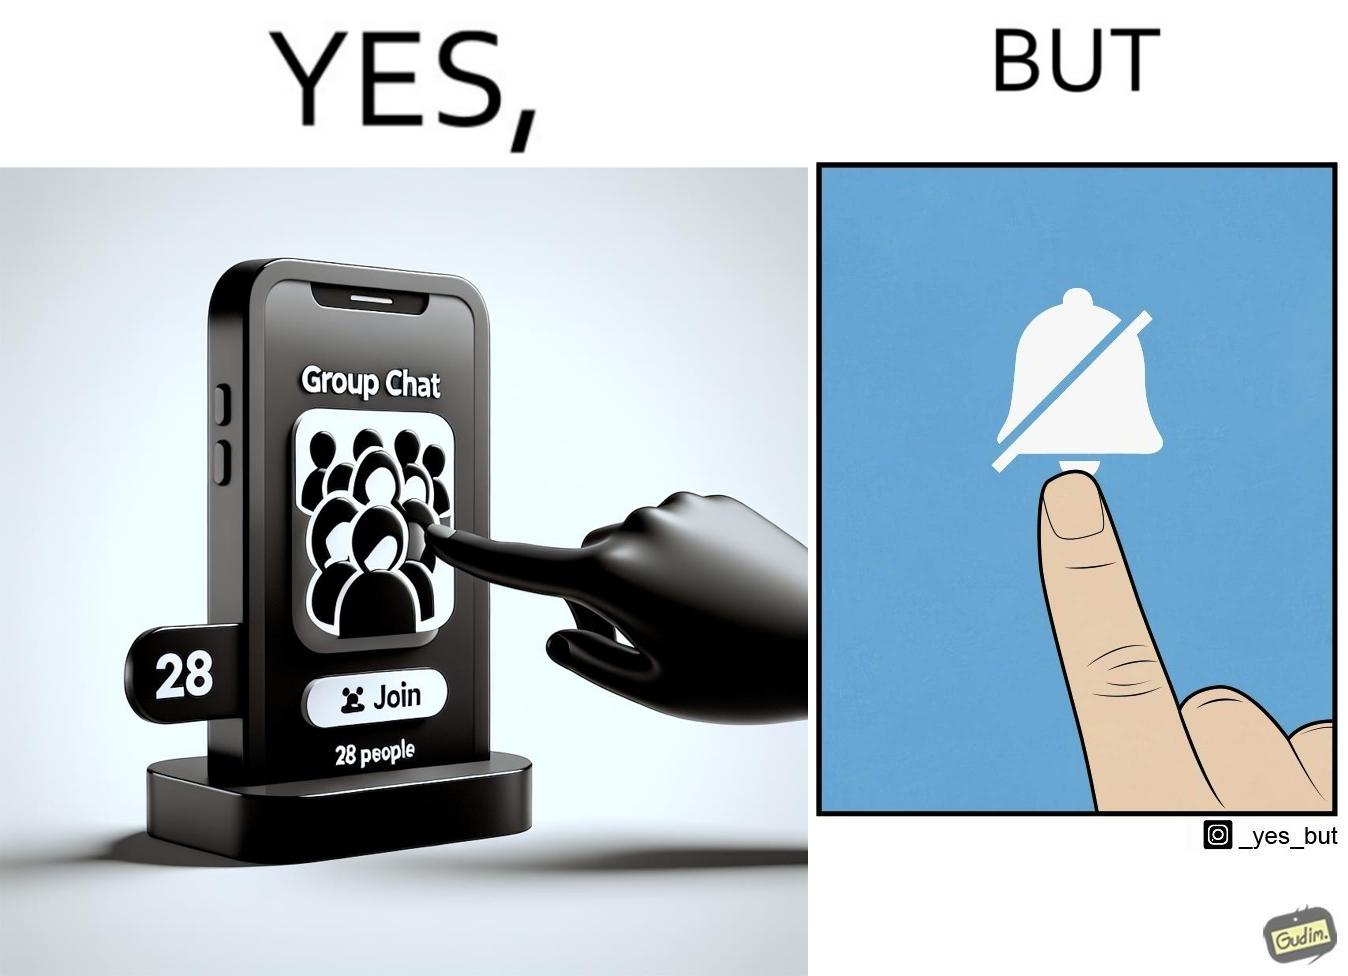Explain why this image is satirical. This is ironic because the person joining the big social group, presumably interested in the happenings of that group, motivated to engage with these people, MUTEs the group as soon as they join it, indicating they are not interested in it and do not  want to be bothered by it.  These actions are contradictory from a social perspective, and illuminate a weird fact about present day online life. 